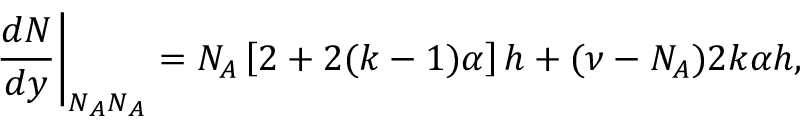<formula> <loc_0><loc_0><loc_500><loc_500>\frac { d N } { d y } \right | _ { N _ { A } N _ { A } } = N _ { A } \left [ 2 + 2 ( k - 1 ) \alpha \right ] h + ( \nu - N _ { A } ) 2 k \alpha h ,</formula> 